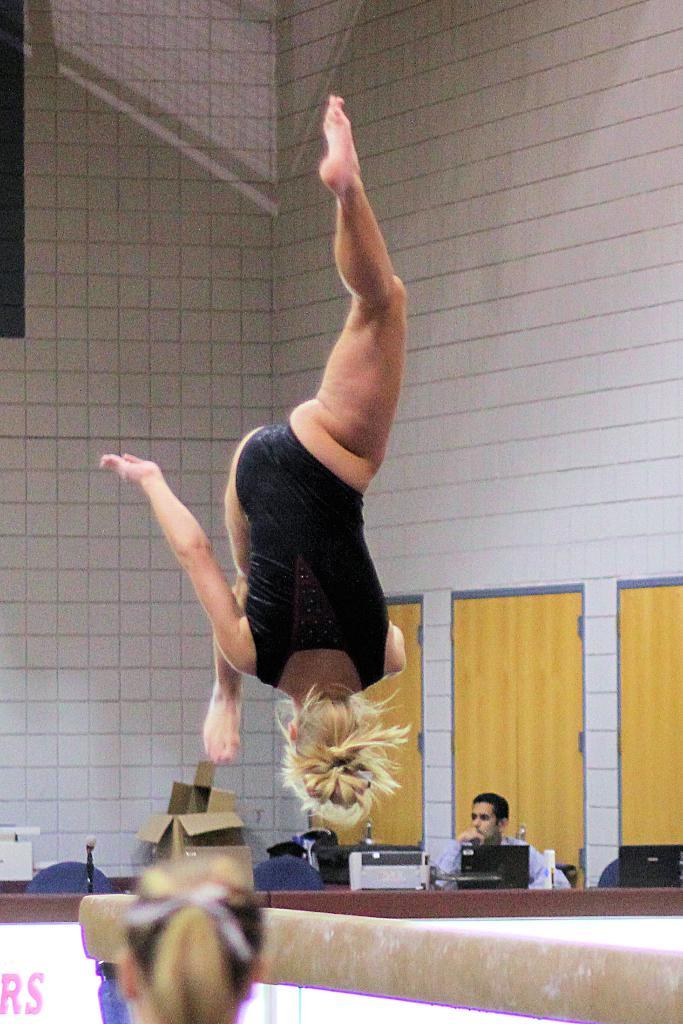What is the main action being performed by the person in the image? The person is performing a gymnastics move in the image. Can you describe the specific gymnastics move being performed? The person is jumping upside down in the air. What can be seen in the background of the image? There is a man sitting in front of a desktop in the background of the image. How many locks are visible on the person performing the gymnastics move in the image? There are no locks visible on the person performing the gymnastics move in the image. What type of stem is being used by the person to perform the gymnastics move in the image? There is no stem involved in the gymnastics move being performed in the image. 